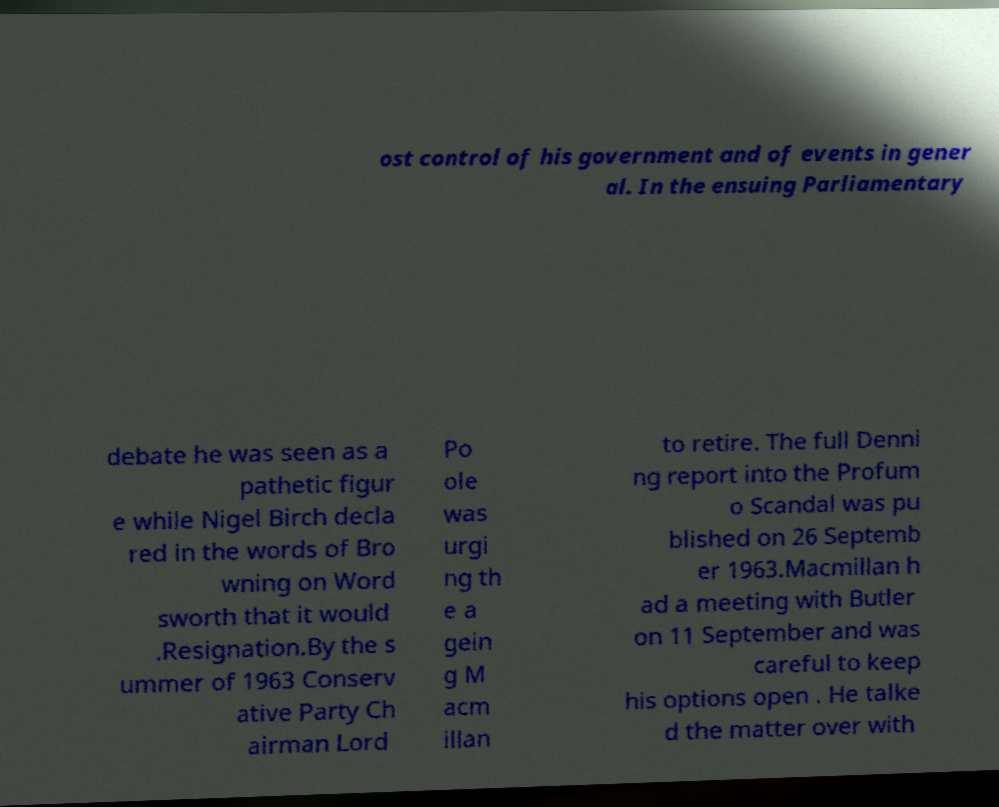Please read and relay the text visible in this image. What does it say? ost control of his government and of events in gener al. In the ensuing Parliamentary debate he was seen as a pathetic figur e while Nigel Birch decla red in the words of Bro wning on Word sworth that it would .Resignation.By the s ummer of 1963 Conserv ative Party Ch airman Lord Po ole was urgi ng th e a gein g M acm illan to retire. The full Denni ng report into the Profum o Scandal was pu blished on 26 Septemb er 1963.Macmillan h ad a meeting with Butler on 11 September and was careful to keep his options open . He talke d the matter over with 